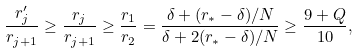<formula> <loc_0><loc_0><loc_500><loc_500>\frac { r ^ { \prime } _ { j } } { r _ { j + 1 } } \geq \frac { r _ { j } } { r _ { j + 1 } } \geq \frac { r _ { 1 } } { r _ { 2 } } = \frac { \delta + ( r _ { * } - \delta ) / N } { \delta + 2 ( r _ { * } - \delta ) / N } \geq \frac { 9 + Q } { 1 0 } ,</formula> 